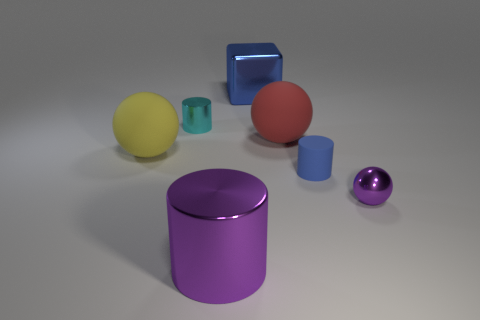The metallic ball is what color?
Make the answer very short. Purple. There is a tiny shiny thing behind the metal ball; does it have the same color as the small sphere?
Provide a succinct answer. No. What material is the thing that is the same color as the tiny sphere?
Give a very brief answer. Metal. How many tiny metallic balls have the same color as the big cylinder?
Your answer should be very brief. 1. Is the shape of the small object that is in front of the blue matte thing the same as  the blue metal object?
Give a very brief answer. No. Is the number of small cyan metal cylinders to the left of the small metallic cylinder less than the number of shiny blocks in front of the blue cylinder?
Provide a succinct answer. No. There is a blue object that is on the right side of the big blue object; what is it made of?
Your response must be concise. Rubber. There is a cube that is the same color as the matte cylinder; what is its size?
Provide a short and direct response. Large. Is there another red rubber thing that has the same size as the red thing?
Make the answer very short. No. Does the big yellow rubber object have the same shape as the big metallic object right of the large purple cylinder?
Make the answer very short. No. 